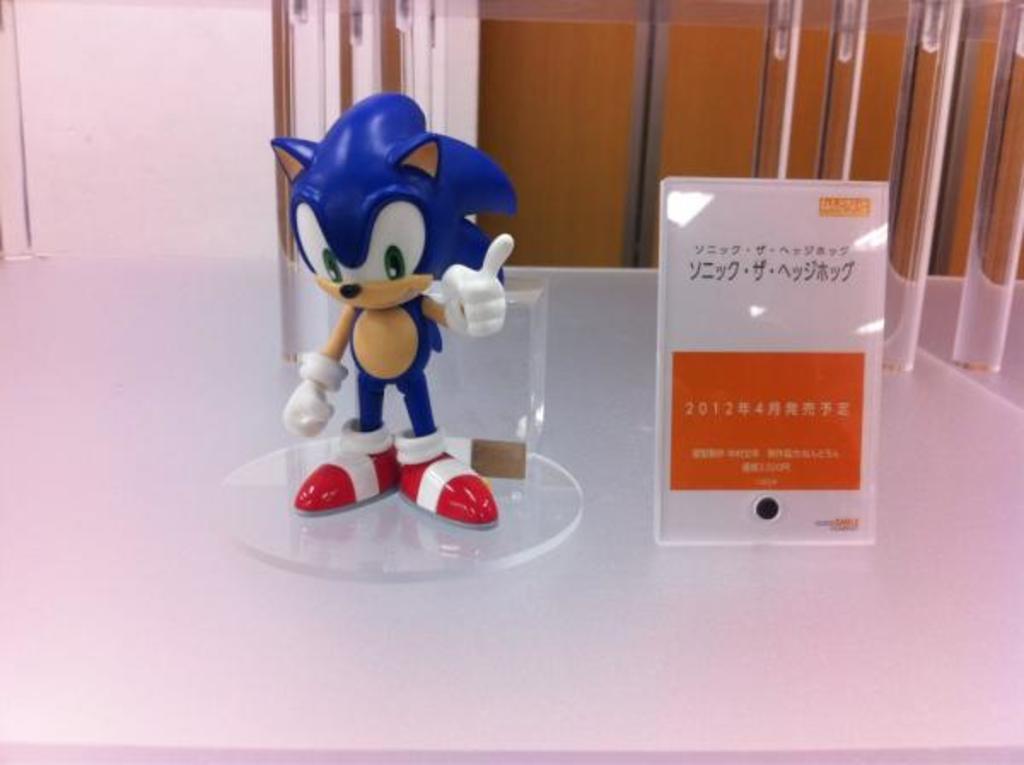Describe this image in one or two sentences. In this image I can see a toy and I can see a glass board and the toy is kept on glass. 